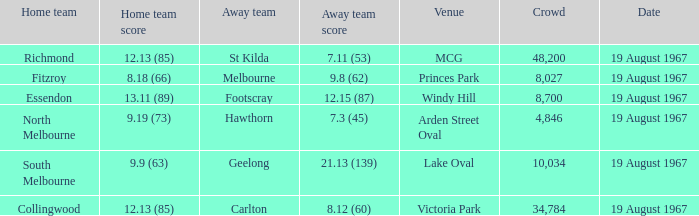If the guest team scored 9.19 (73). 